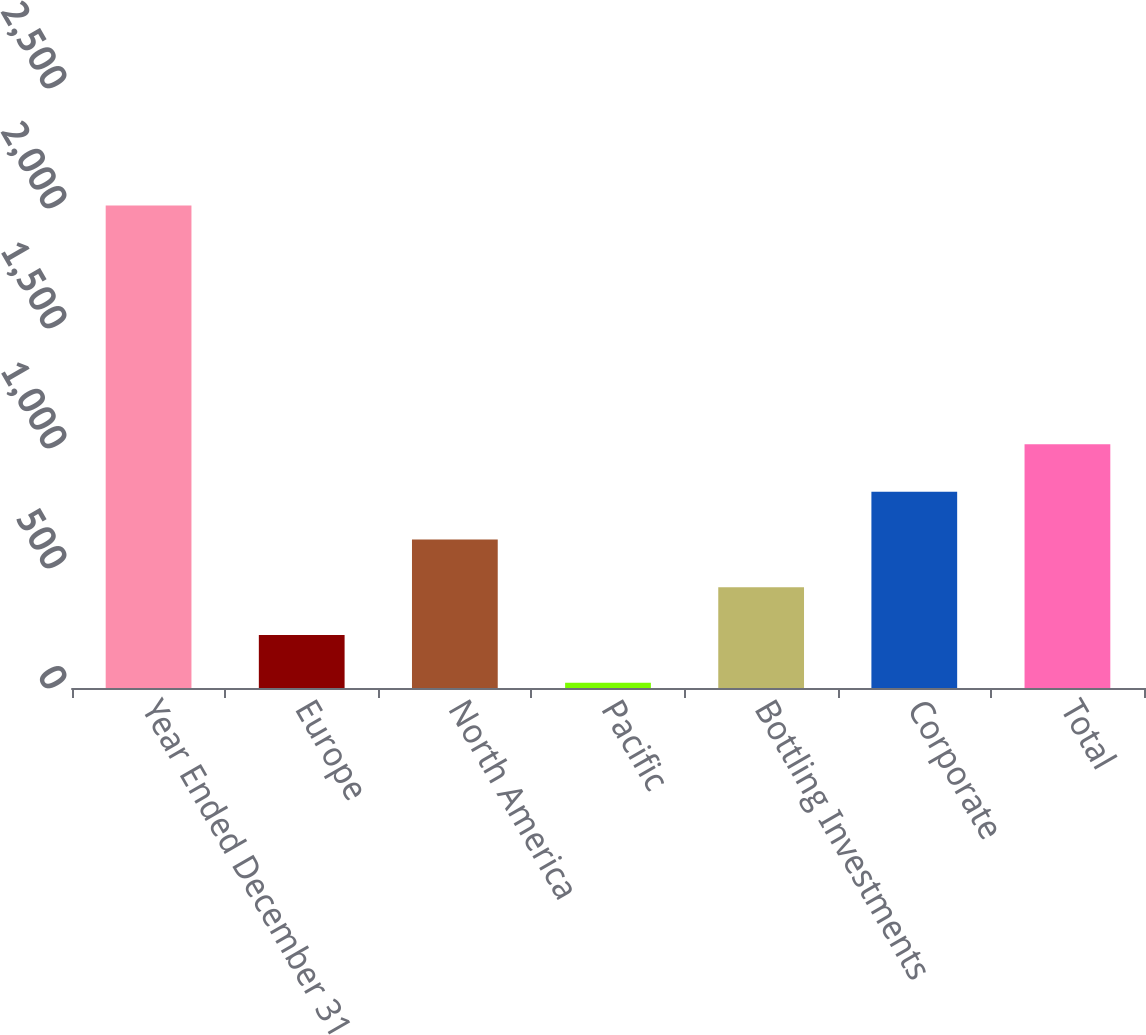<chart> <loc_0><loc_0><loc_500><loc_500><bar_chart><fcel>Year Ended December 31<fcel>Europe<fcel>North America<fcel>Pacific<fcel>Bottling Investments<fcel>Corporate<fcel>Total<nl><fcel>2010<fcel>220.8<fcel>618.4<fcel>22<fcel>419.6<fcel>817.2<fcel>1016<nl></chart> 